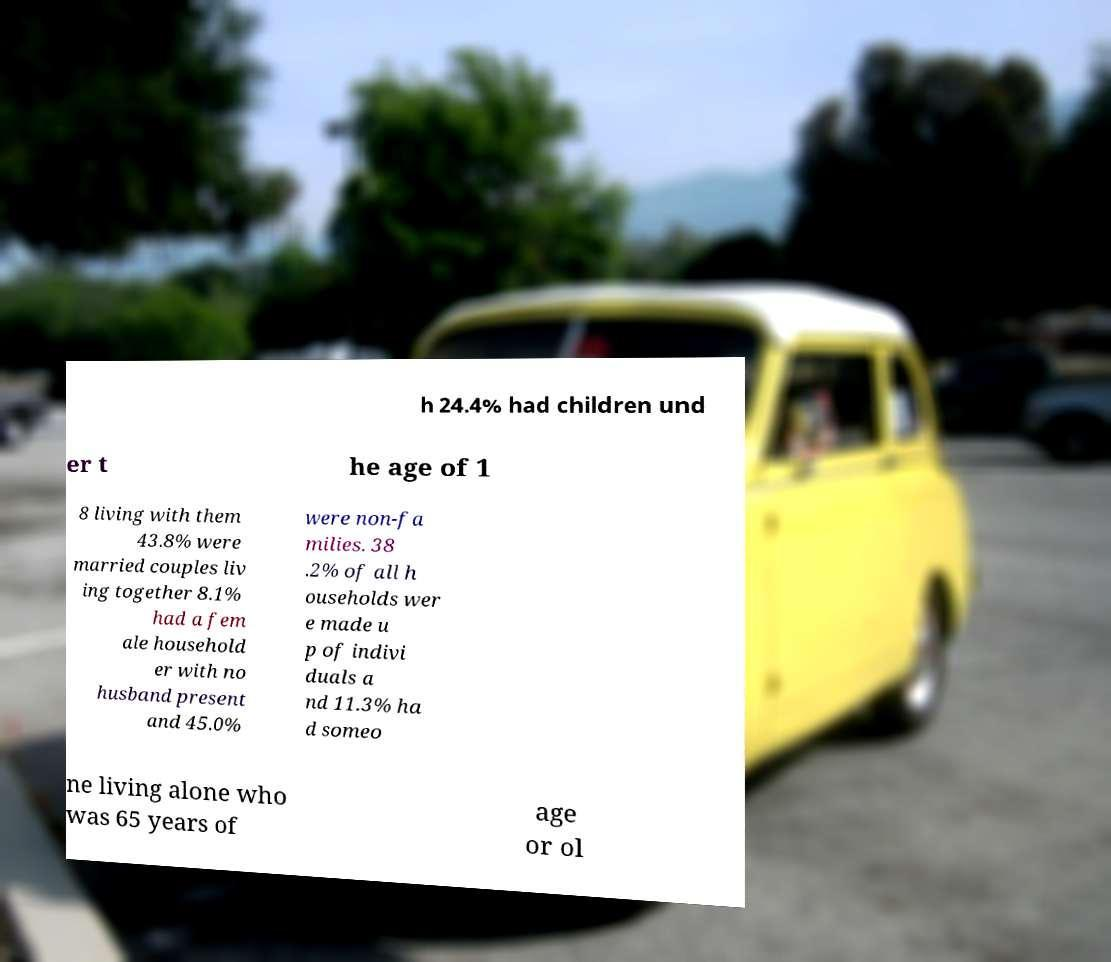Could you extract and type out the text from this image? h 24.4% had children und er t he age of 1 8 living with them 43.8% were married couples liv ing together 8.1% had a fem ale household er with no husband present and 45.0% were non-fa milies. 38 .2% of all h ouseholds wer e made u p of indivi duals a nd 11.3% ha d someo ne living alone who was 65 years of age or ol 